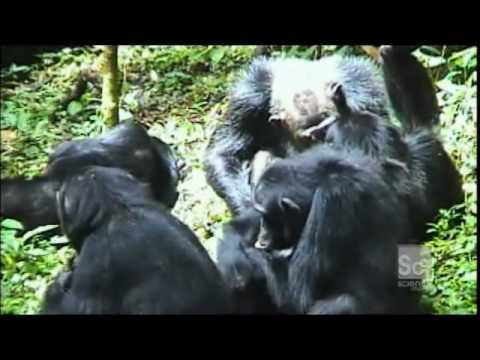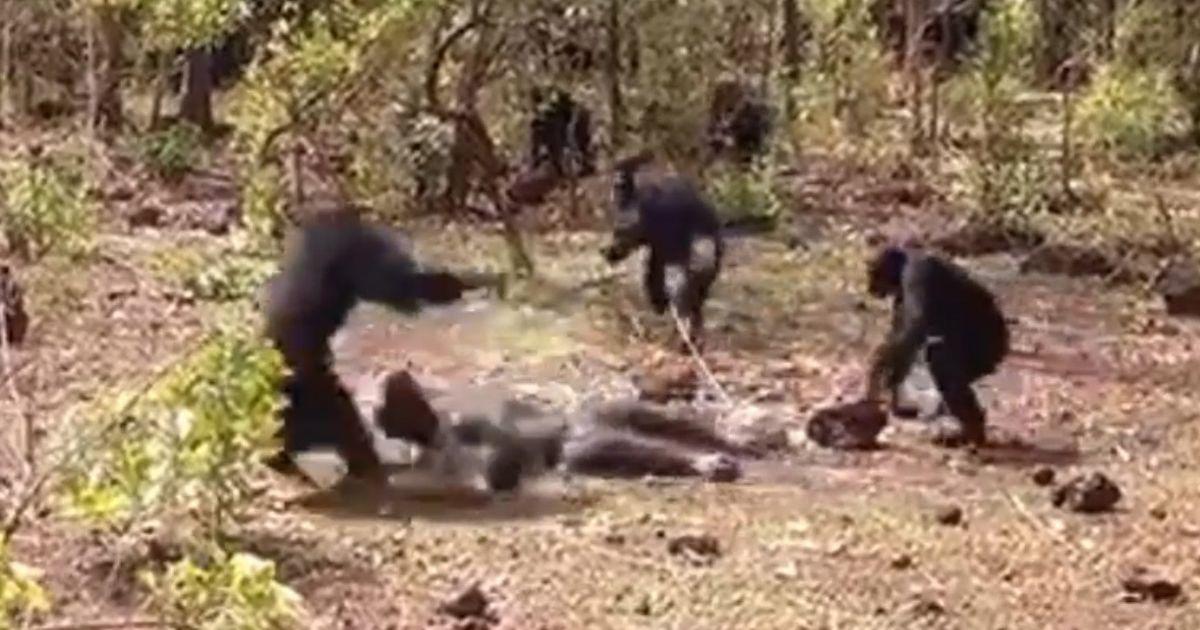The first image is the image on the left, the second image is the image on the right. Given the left and right images, does the statement "There is a furniture near a chimpanzee in at least one of the images." hold true? Answer yes or no. No. The first image is the image on the left, the second image is the image on the right. Evaluate the accuracy of this statement regarding the images: "One image shows multiple chimps gathered around a prone figure on the ground in a clearing.". Is it true? Answer yes or no. Yes. 